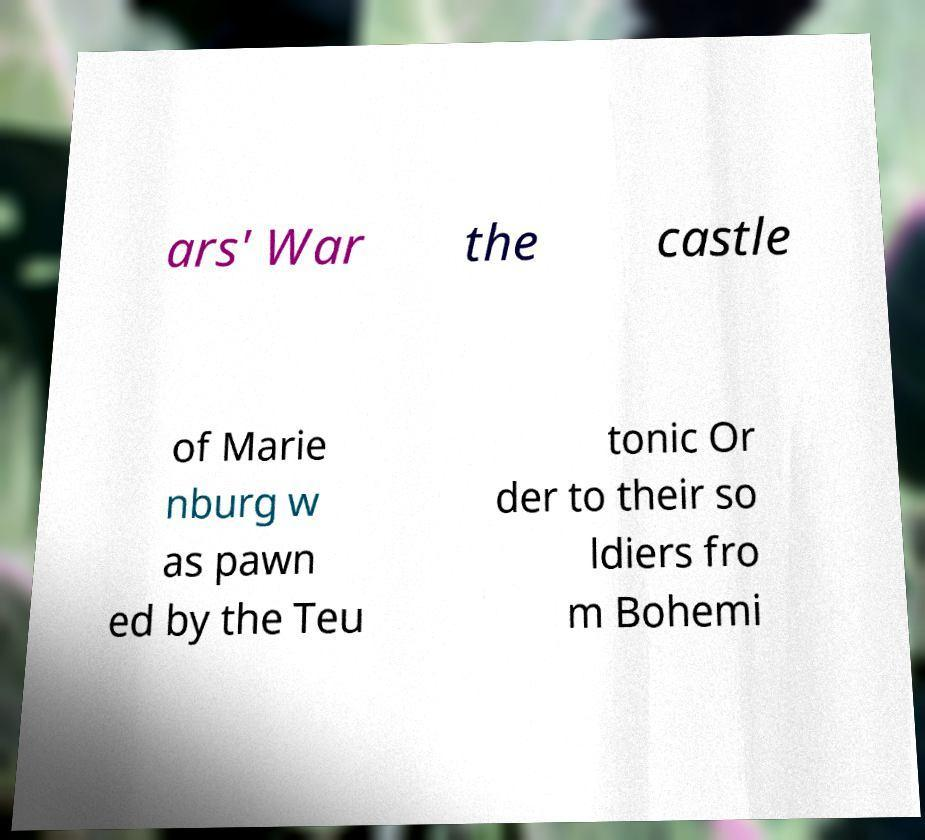Could you assist in decoding the text presented in this image and type it out clearly? ars' War the castle of Marie nburg w as pawn ed by the Teu tonic Or der to their so ldiers fro m Bohemi 